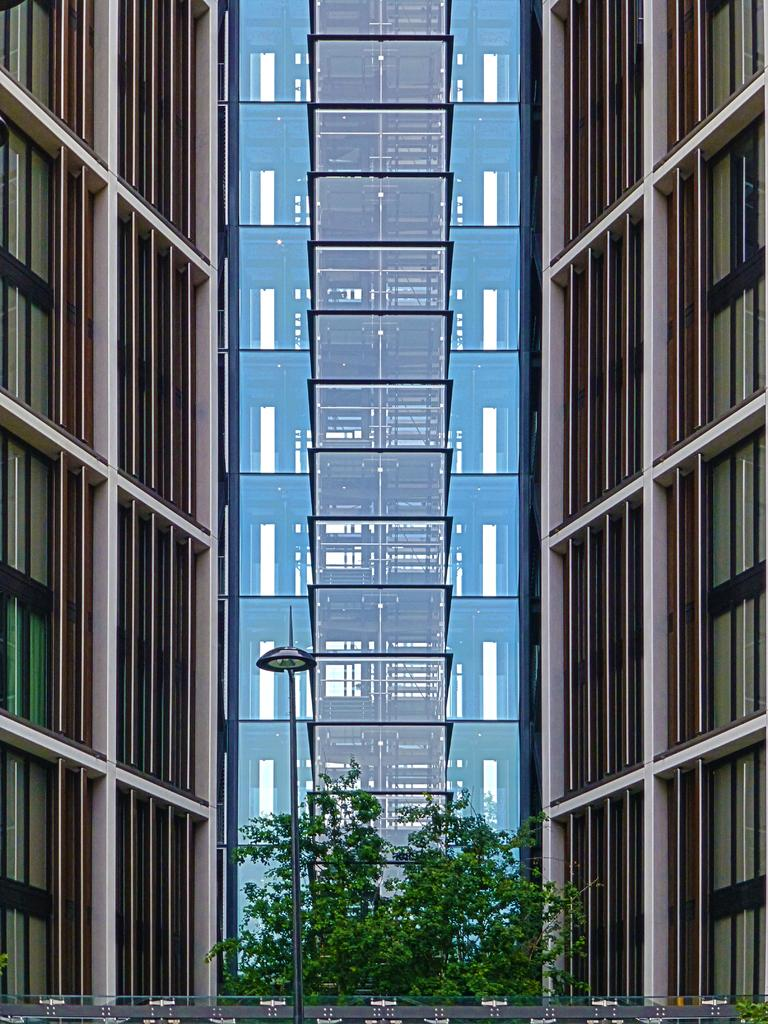What type of natural elements can be seen in the image? There are trees in the image. What artificial element is present in the image? There is a street light in the image. What type of structures can be seen in the background of the image? There are buildings in the background of the image. Can you describe the object at the bottom of the image? Unfortunately, the facts provided do not give any information about the object at the bottom of the image. Is there a large crowd gathered around the street light in the image? No, there is no mention of a crowd in the image. What type of operation is being performed on the trees in the image? There is no operation being performed on the trees in the image; they are simply standing. 